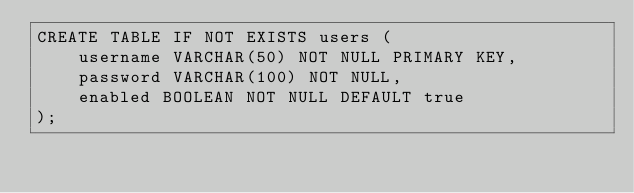<code> <loc_0><loc_0><loc_500><loc_500><_SQL_>CREATE TABLE IF NOT EXISTS users (
	username VARCHAR(50) NOT NULL PRIMARY KEY,
	password VARCHAR(100) NOT NULL,
	enabled BOOLEAN NOT NULL DEFAULT true
);</code> 